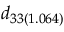Convert formula to latex. <formula><loc_0><loc_0><loc_500><loc_500>d _ { 3 3 ( 1 . 0 6 4 ) }</formula> 